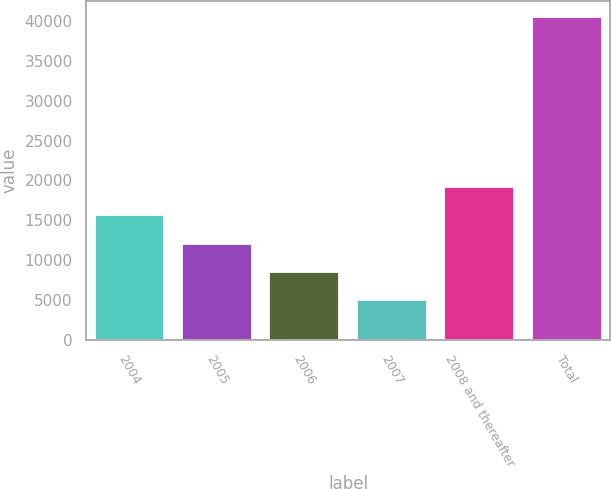<chart> <loc_0><loc_0><loc_500><loc_500><bar_chart><fcel>2004<fcel>2005<fcel>2006<fcel>2007<fcel>2008 and thereafter<fcel>Total<nl><fcel>15639.8<fcel>12086.2<fcel>8532.6<fcel>4979<fcel>19193.4<fcel>40515<nl></chart> 